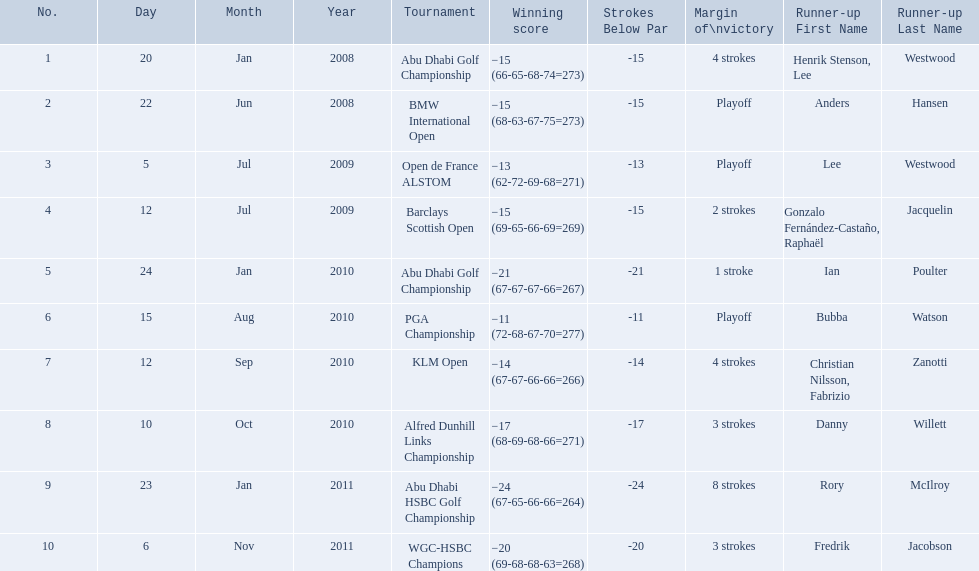Which tournaments did martin kaymer participate in? Abu Dhabi Golf Championship, BMW International Open, Open de France ALSTOM, Barclays Scottish Open, Abu Dhabi Golf Championship, PGA Championship, KLM Open, Alfred Dunhill Links Championship, Abu Dhabi HSBC Golf Championship, WGC-HSBC Champions. How many of these tournaments were won through a playoff? BMW International Open, Open de France ALSTOM, PGA Championship. Which of those tournaments took place in 2010? PGA Championship. Who had to top score next to martin kaymer for that tournament? Bubba Watson. 